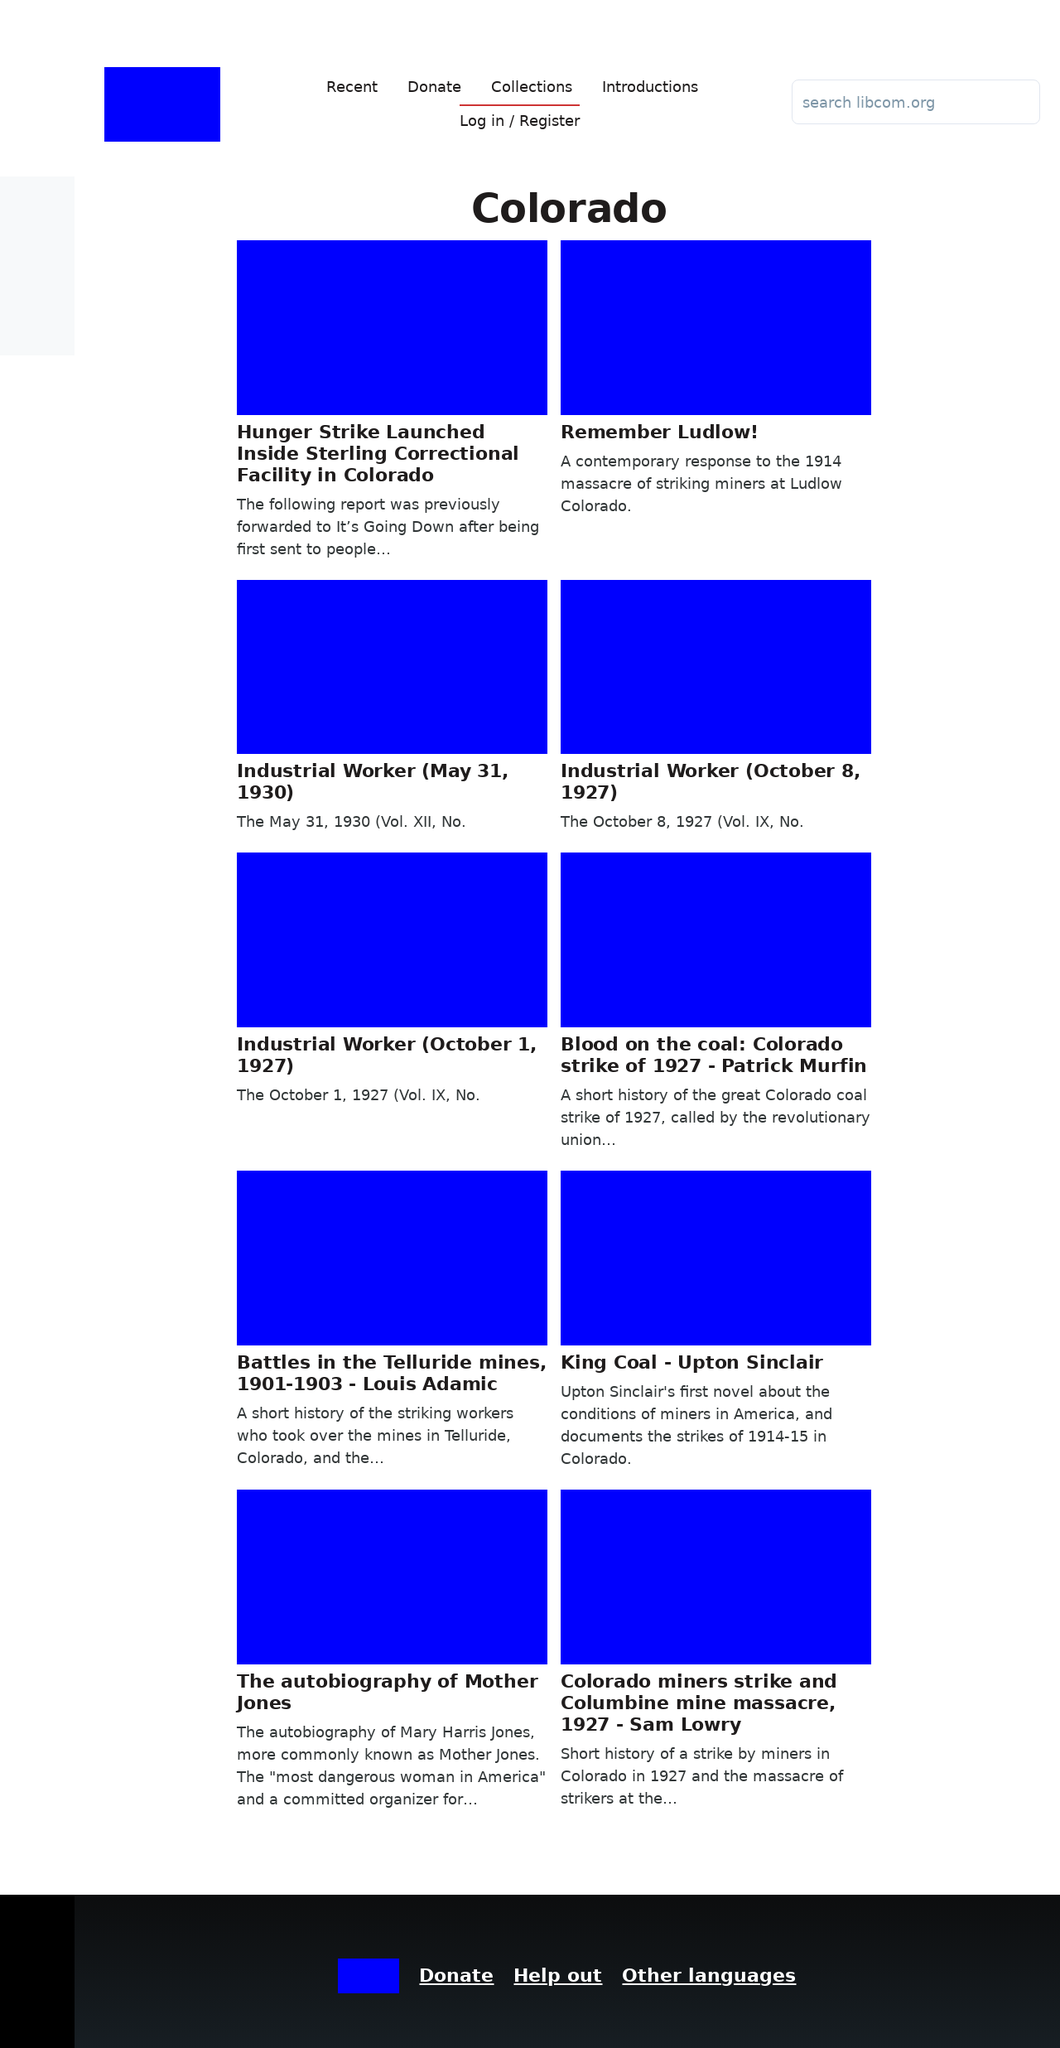What is the overall theme or purpose of this website based on the visible content? Based on the displayed content, the theme of the website revolves around providing historical and current insights into significant events in Colorado, particularly labor strikes and worker rights. The articles showcase a historical perspective on the labor movement with a focus on the mining industry, as well as ongoing social issues within correctional facilities, demonstrating the website's focus on social justice and historical education. 